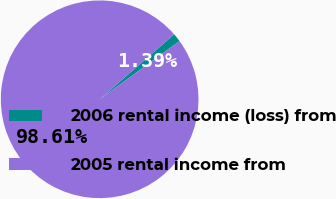Convert chart to OTSL. <chart><loc_0><loc_0><loc_500><loc_500><pie_chart><fcel>2006 rental income (loss) from<fcel>2005 rental income from<nl><fcel>1.39%<fcel>98.61%<nl></chart> 